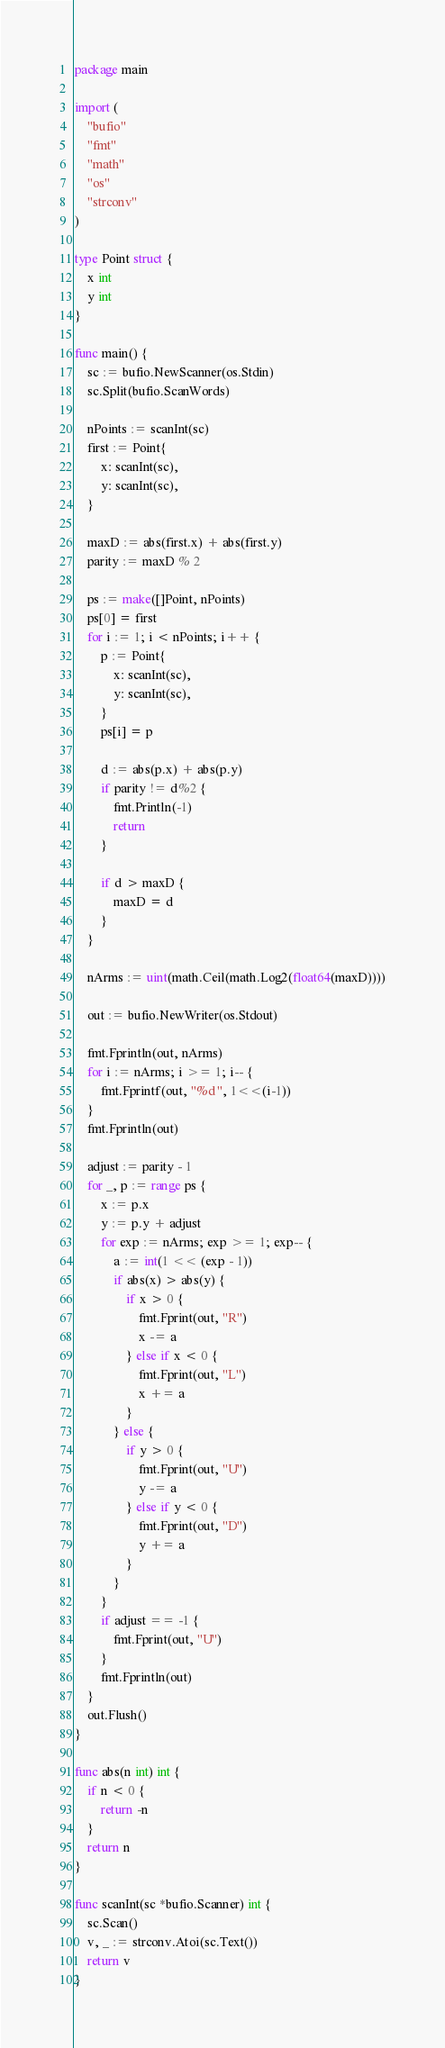Convert code to text. <code><loc_0><loc_0><loc_500><loc_500><_Go_>package main

import (
	"bufio"
	"fmt"
	"math"
	"os"
	"strconv"
)

type Point struct {
	x int
	y int
}

func main() {
	sc := bufio.NewScanner(os.Stdin)
	sc.Split(bufio.ScanWords)

	nPoints := scanInt(sc)
	first := Point{
		x: scanInt(sc),
		y: scanInt(sc),
	}

	maxD := abs(first.x) + abs(first.y)
	parity := maxD % 2

	ps := make([]Point, nPoints)
	ps[0] = first
	for i := 1; i < nPoints; i++ {
		p := Point{
			x: scanInt(sc),
			y: scanInt(sc),
		}
		ps[i] = p

		d := abs(p.x) + abs(p.y)
		if parity != d%2 {
			fmt.Println(-1)
			return
		}

		if d > maxD {
			maxD = d
		}
	}

	nArms := uint(math.Ceil(math.Log2(float64(maxD))))

	out := bufio.NewWriter(os.Stdout)

	fmt.Fprintln(out, nArms)
	for i := nArms; i >= 1; i-- {
		fmt.Fprintf(out, "%d ", 1<<(i-1))
	}
	fmt.Fprintln(out)

	adjust := parity - 1
	for _, p := range ps {
		x := p.x
		y := p.y + adjust
		for exp := nArms; exp >= 1; exp-- {
			a := int(1 << (exp - 1))
			if abs(x) > abs(y) {
				if x > 0 {
					fmt.Fprint(out, "R")
					x -= a
				} else if x < 0 {
					fmt.Fprint(out, "L")
					x += a
				}
			} else {
				if y > 0 {
					fmt.Fprint(out, "U")
					y -= a
				} else if y < 0 {
					fmt.Fprint(out, "D")
					y += a
				}
			}
		}
		if adjust == -1 {
			fmt.Fprint(out, "U")
		}
		fmt.Fprintln(out)
	}
	out.Flush()
}

func abs(n int) int {
	if n < 0 {
		return -n
	}
	return n
}

func scanInt(sc *bufio.Scanner) int {
	sc.Scan()
	v, _ := strconv.Atoi(sc.Text())
	return v
}
</code> 